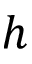<formula> <loc_0><loc_0><loc_500><loc_500>h</formula> 